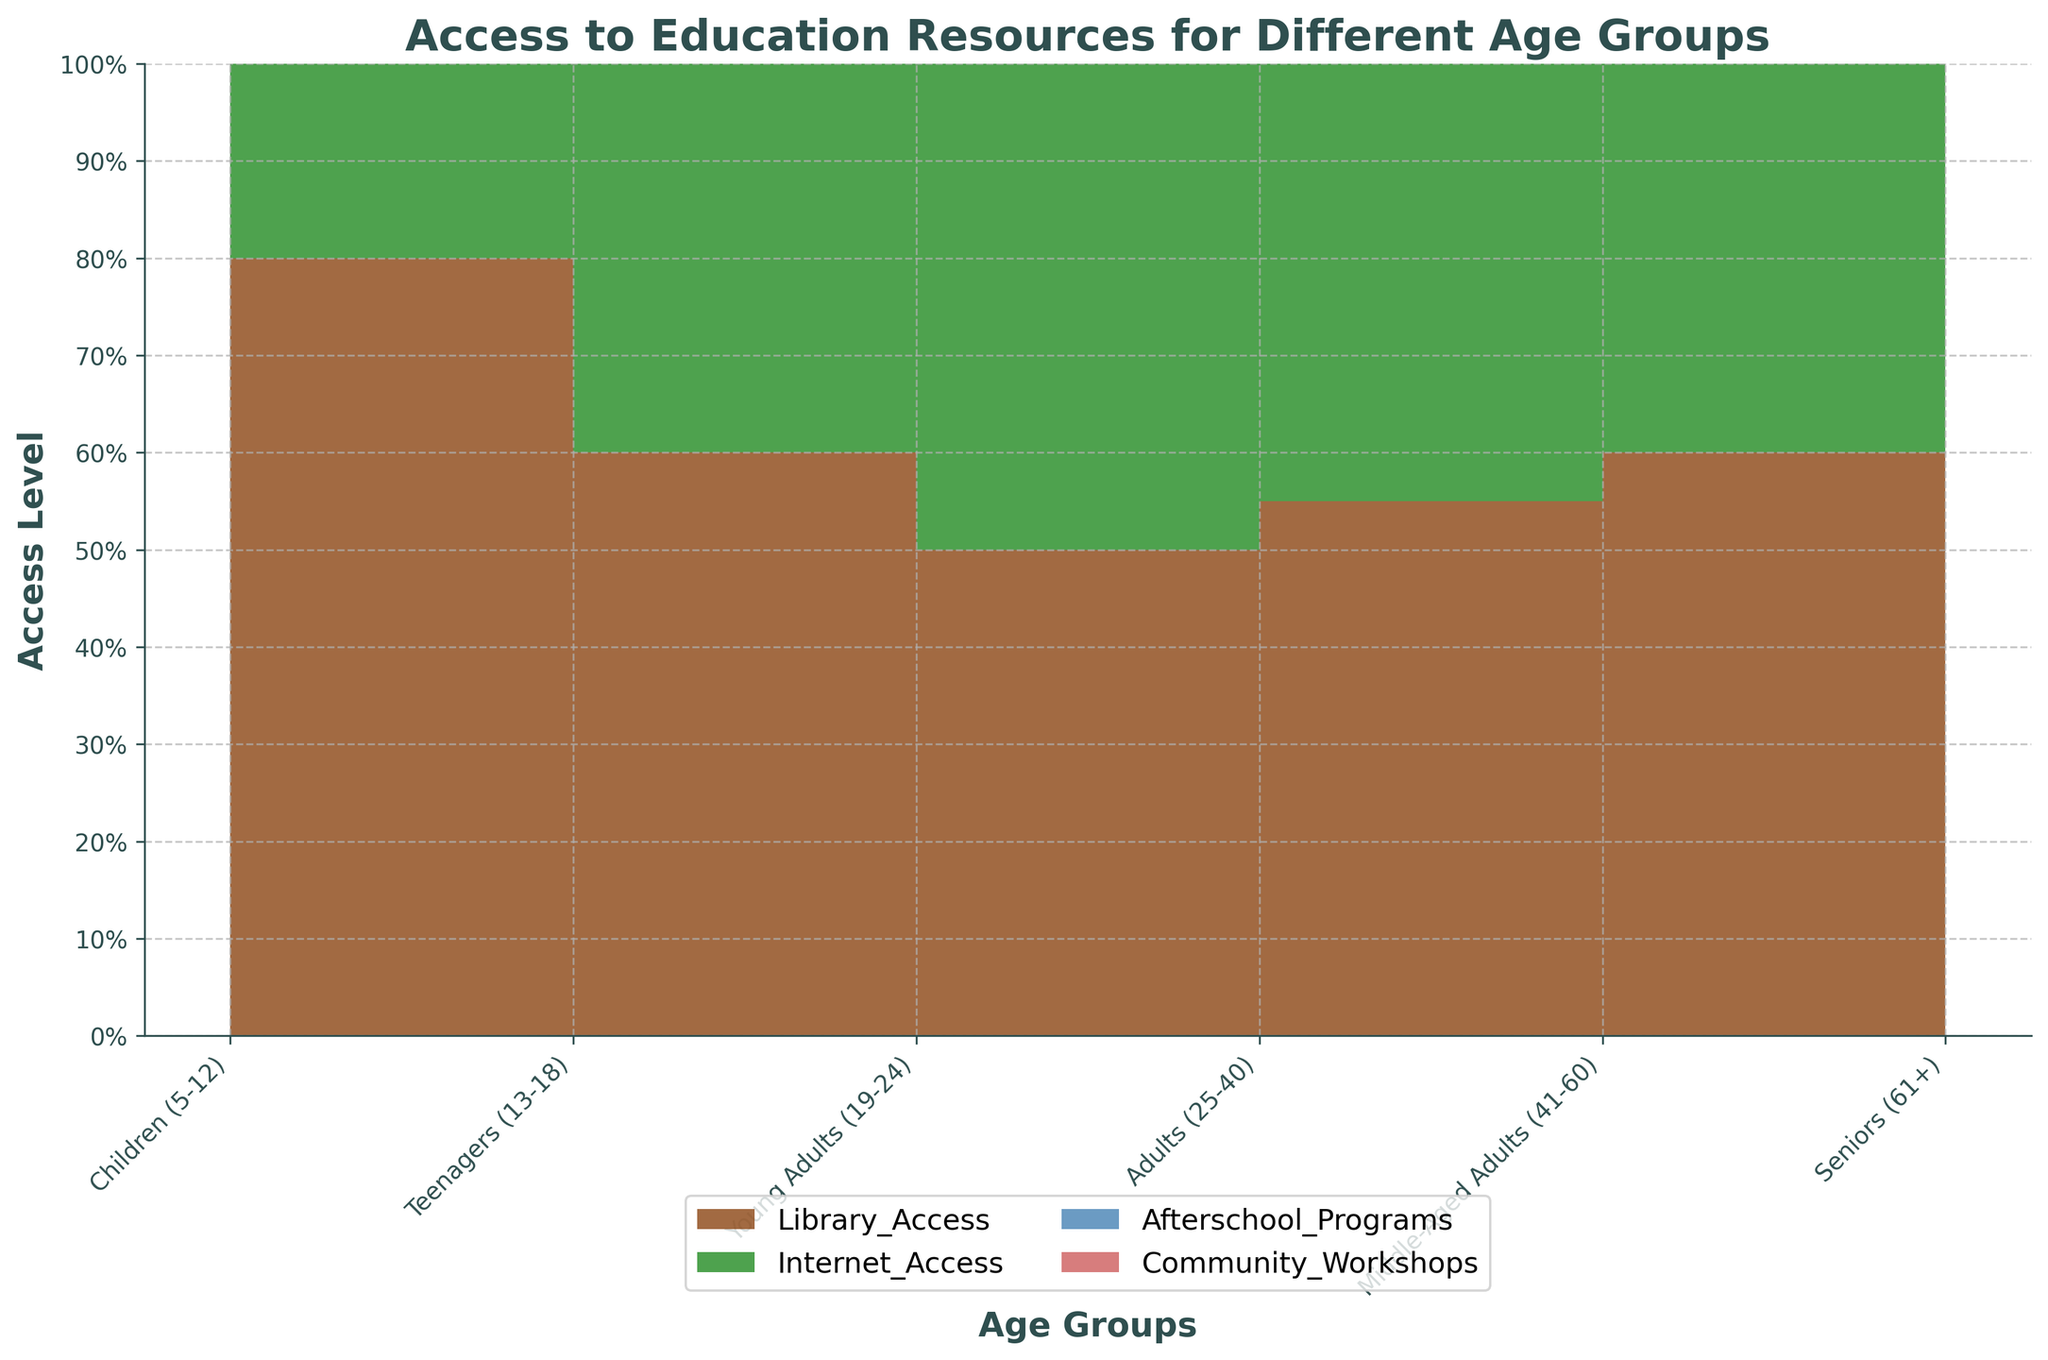What does the title of the chart say? The title of the chart provides a summary of what the figure is about. In this case, it is "Access to Education Resources for Different Age Groups."
Answer: Access to Education Resources for Different Age Groups What age group has the highest library access rate? By looking at the section corresponding to library access across age groups, the group with the highest area will indicate the highest access rate. In this case, it is the Teenagers (13-18) group.
Answer: Teenagers (13-18) How does internet access change from Children (5-12) to Adults (25-40)? To determine how internet access changes, observe the trend of the internet access area from Children (5-12) to Adults (25-40). It increases as we move from Children (5-12) to Young Adults (19-24) and remains constant up to Adults (25-40).
Answer: It increases Which age group has the least access to afterschool programs? Identify the segment with the smallest area representing afterschool programs across all age groups. Here, Seniors (61+) have the smallest area for afterschool programs.
Answer: Seniors (61+) Do any age groups have a similar level of community workshops access? Look at the areas for community workshops access and compare them across different age groups. Middle-Aged Adults (41-60) at 0.75 and Seniors (61+) at 0.80 have similar levels of access.
Answer: Middle-Aged Adults (41-60) and Seniors (61+) Which educational resource shows the most dramatic decrease in access from one age group to another? To find a dramatic decrease, observe the steepest drop in any colored area representing a resource between two consecutive age groups. Afterschool programs drop significantly from Teenagers (13-18) at 0.70 to Young Adults (19-24) at 0.40.
Answer: Afterschool programs from Teenagers (13-18) to Young Adults (19-24) Which resource shows the most consistent level of access across all age groups? Observe the areas of each resource and identify which one has the least fluctuation across age groups. Internet access remains relatively consistent across all age groups.
Answer: Internet access How does access to community workshops change from Young Adults (19-24) to Seniors (61+)? Compare the access levels of community workshops from Young Adults (19-24) at 0.65 to Seniors (61+) at 0.80 to understand the trend.
Answer: It increases Which age group has the highest levels of access to education resources overall? To determine this, sum the areas for all educational resources for each age group and compare them. Children (5-12) have the highest overall access when combining all resources.
Answer: Children (5-12) How much more internet access do Young Adults (19-24) have compared to Seniors (61+)? Calculate the difference in the internet access levels of Young Adults (19-24) at 0.80 and Seniors (61+) at 0.55. The difference is 0.80 - 0.55 = 0.25 or 25%.
Answer: 25% 